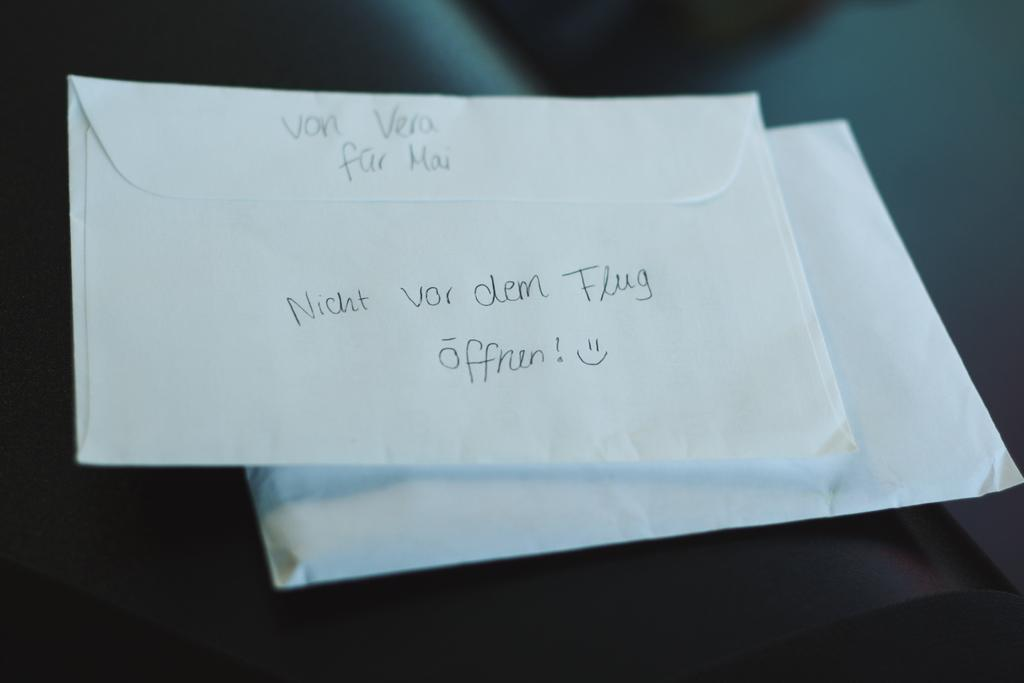<image>
Write a terse but informative summary of the picture. Von Vera far Mai is hand written on the back of an envelope. 